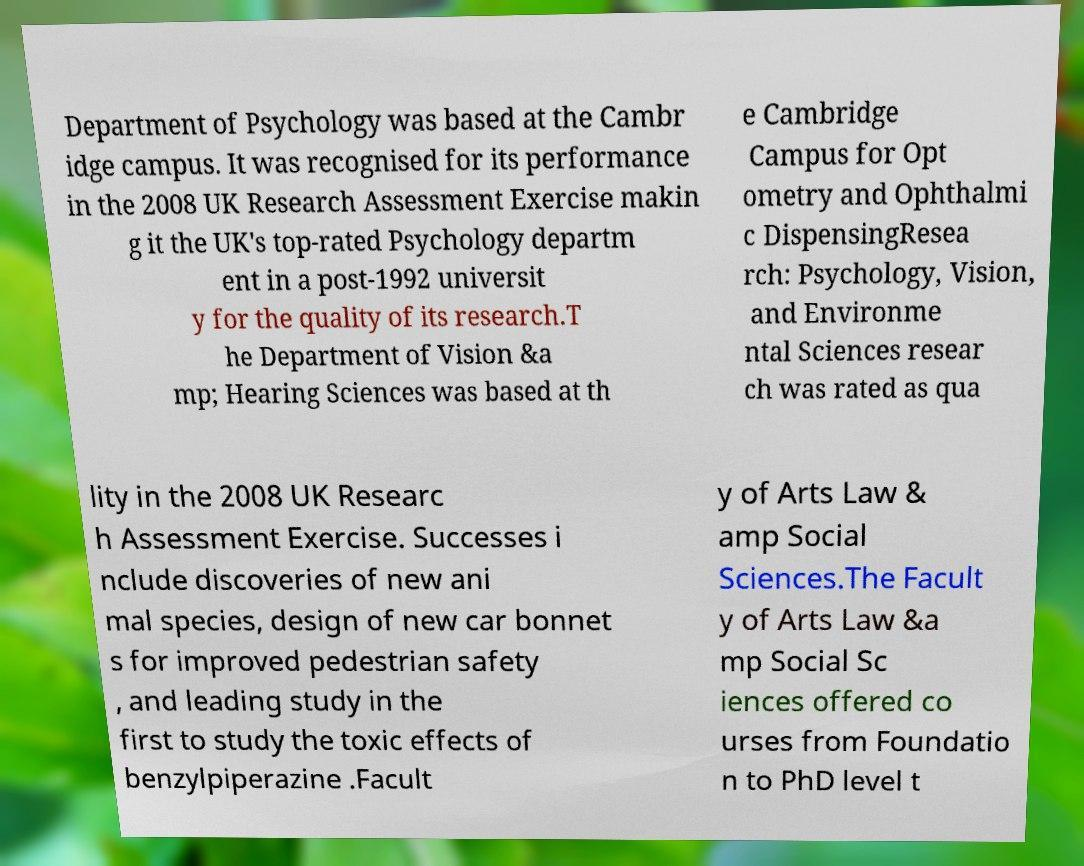Can you read and provide the text displayed in the image?This photo seems to have some interesting text. Can you extract and type it out for me? Department of Psychology was based at the Cambr idge campus. It was recognised for its performance in the 2008 UK Research Assessment Exercise makin g it the UK's top-rated Psychology departm ent in a post-1992 universit y for the quality of its research.T he Department of Vision &a mp; Hearing Sciences was based at th e Cambridge Campus for Opt ometry and Ophthalmi c DispensingResea rch: Psychology, Vision, and Environme ntal Sciences resear ch was rated as qua lity in the 2008 UK Researc h Assessment Exercise. Successes i nclude discoveries of new ani mal species, design of new car bonnet s for improved pedestrian safety , and leading study in the first to study the toxic effects of benzylpiperazine .Facult y of Arts Law & amp Social Sciences.The Facult y of Arts Law &a mp Social Sc iences offered co urses from Foundatio n to PhD level t 